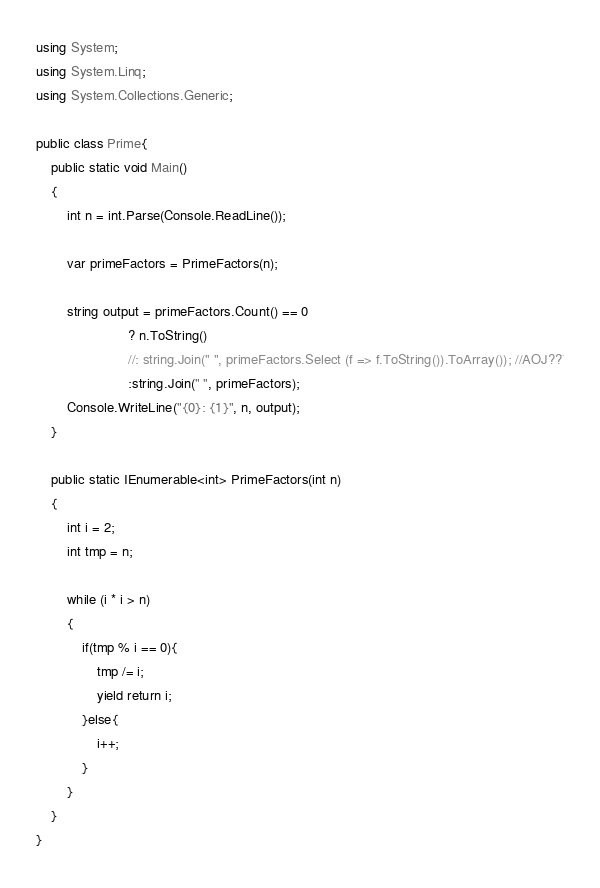<code> <loc_0><loc_0><loc_500><loc_500><_C#_>using System;
using System.Linq;
using System.Collections.Generic;

public class Prime{
    public static void Main()
    {
        int n = int.Parse(Console.ReadLine());
         
        var primeFactors = PrimeFactors(n);
         
        string output = primeFactors.Count() == 0 
                        ? n.ToString() 
                        //: string.Join(" ", primeFactors.Select (f => f.ToString()).ToArray()); //AOJ??¨
                        :string.Join(" ", primeFactors);
        Console.WriteLine("{0}: {1}", n, output);
    }
     
    public static IEnumerable<int> PrimeFactors(int n)
    {
        int i = 2;
        int tmp = n;
         
        while (i * i > n)
        {
            if(tmp % i == 0){
                tmp /= i;
                yield return i;
            }else{
                i++;
            }
        }
    }
}</code> 